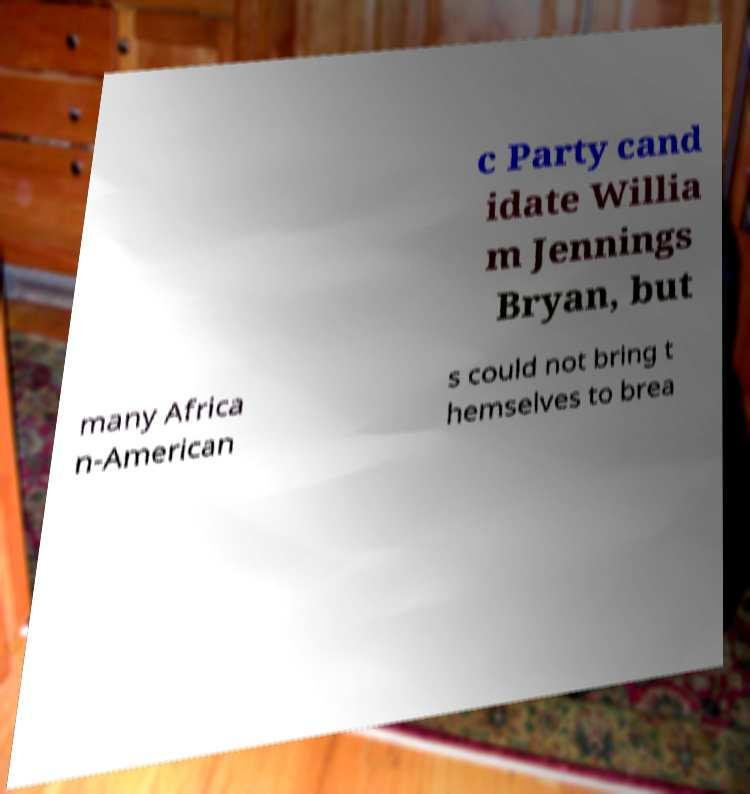Please identify and transcribe the text found in this image. c Party cand idate Willia m Jennings Bryan, but many Africa n-American s could not bring t hemselves to brea 